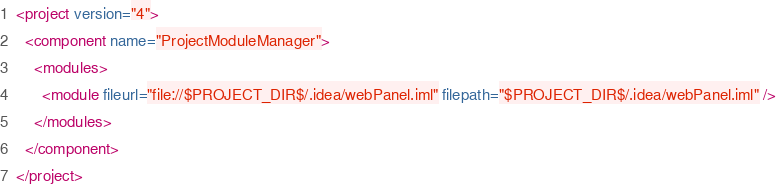Convert code to text. <code><loc_0><loc_0><loc_500><loc_500><_XML_><project version="4">
  <component name="ProjectModuleManager">
    <modules>
      <module fileurl="file://$PROJECT_DIR$/.idea/webPanel.iml" filepath="$PROJECT_DIR$/.idea/webPanel.iml" />
    </modules>
  </component>
</project></code> 